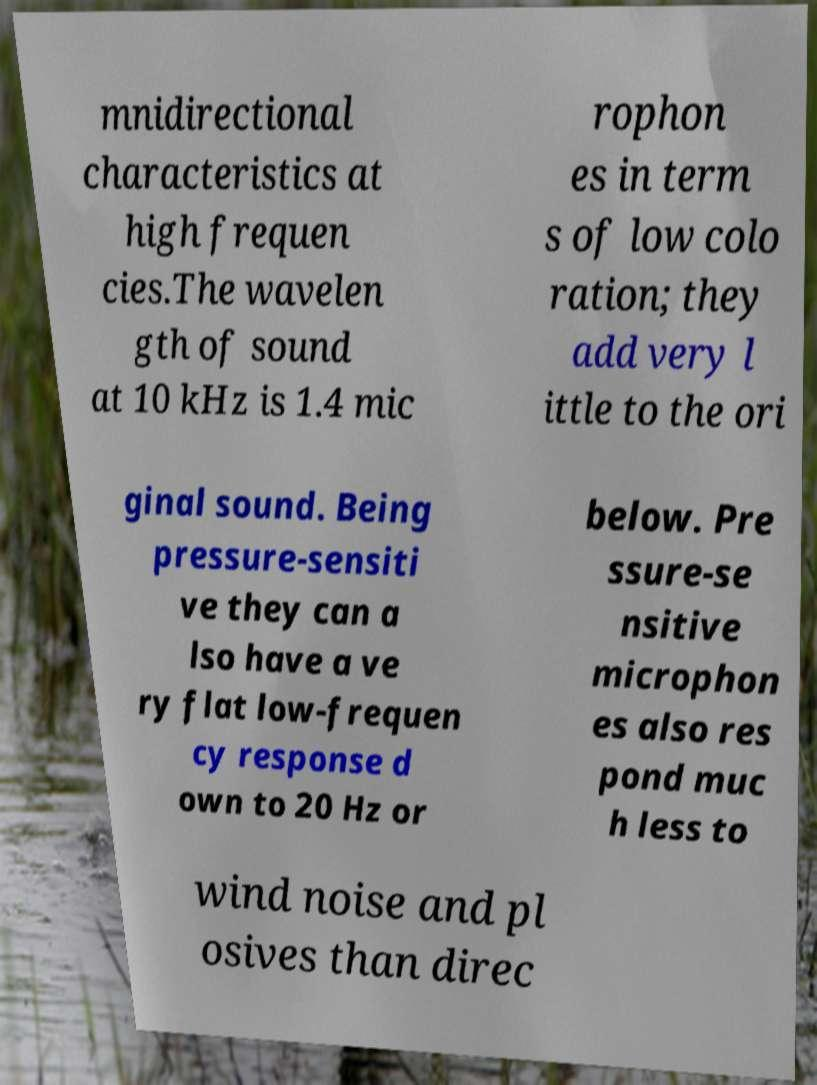There's text embedded in this image that I need extracted. Can you transcribe it verbatim? mnidirectional characteristics at high frequen cies.The wavelen gth of sound at 10 kHz is 1.4 mic rophon es in term s of low colo ration; they add very l ittle to the ori ginal sound. Being pressure-sensiti ve they can a lso have a ve ry flat low-frequen cy response d own to 20 Hz or below. Pre ssure-se nsitive microphon es also res pond muc h less to wind noise and pl osives than direc 